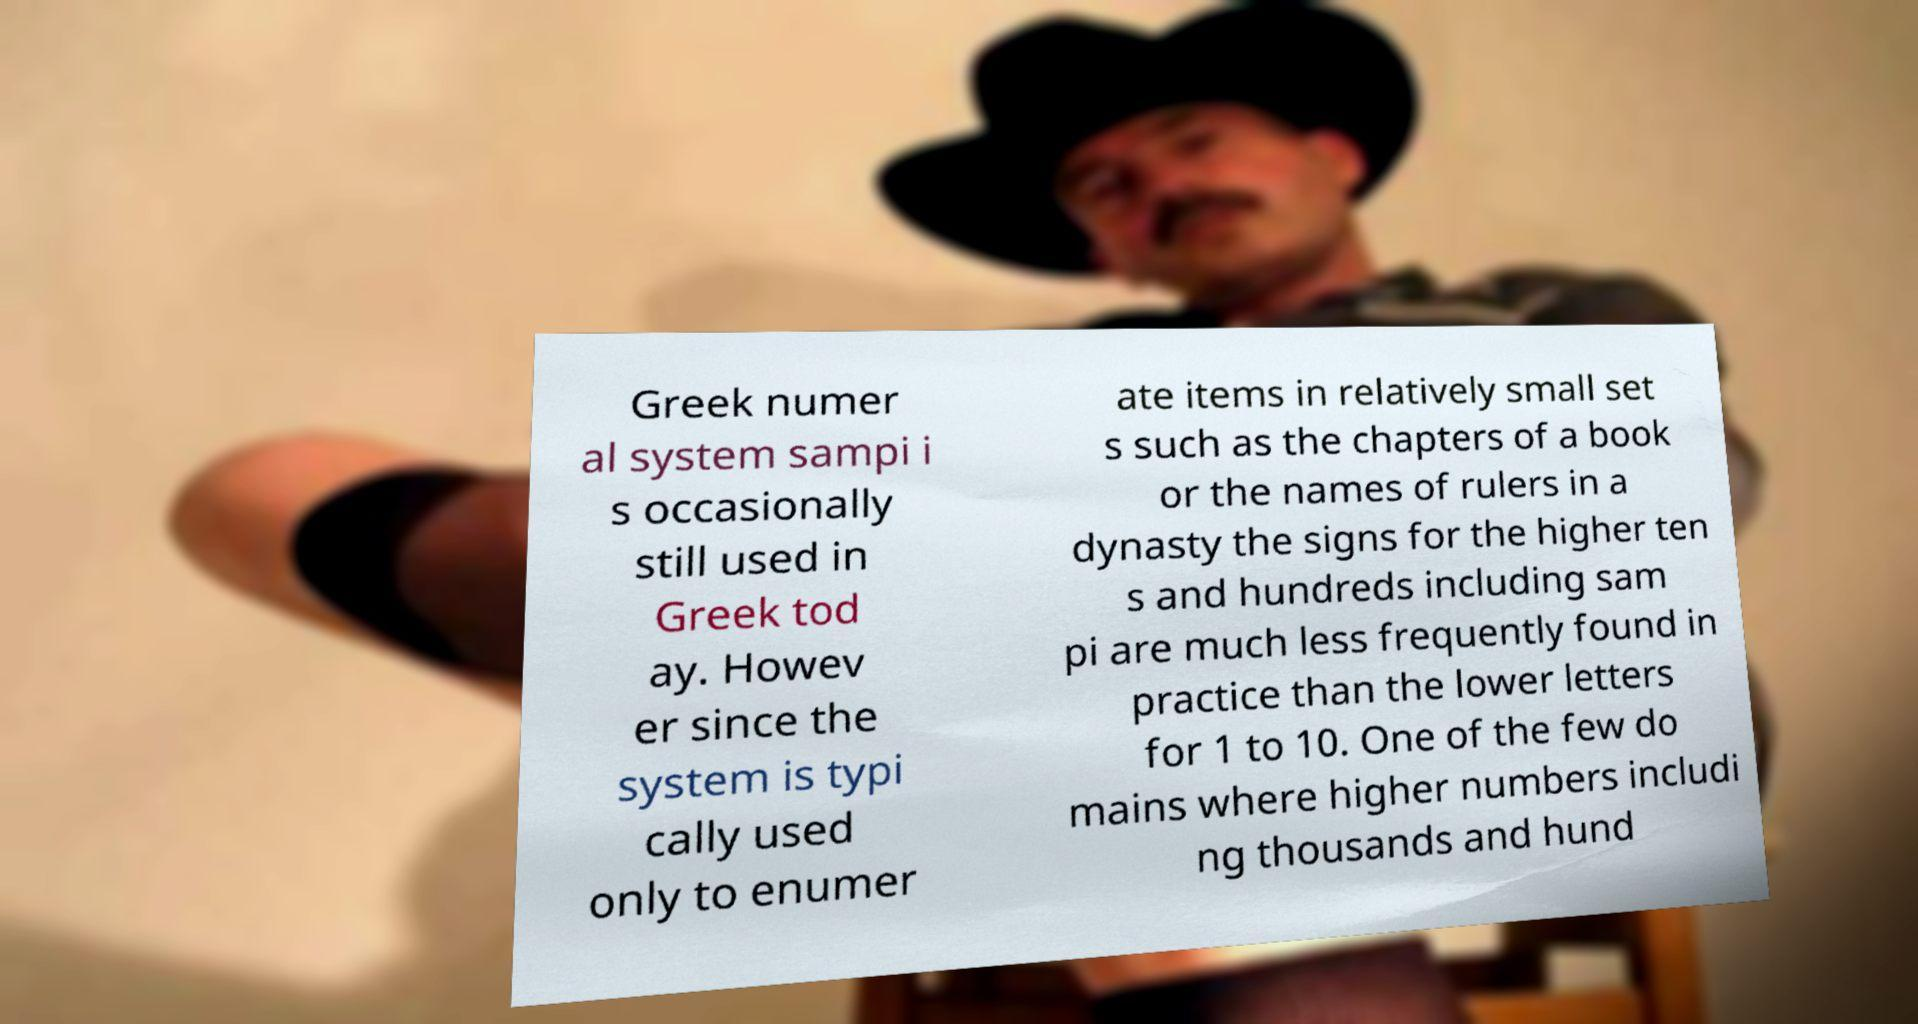Can you read and provide the text displayed in the image?This photo seems to have some interesting text. Can you extract and type it out for me? Greek numer al system sampi i s occasionally still used in Greek tod ay. Howev er since the system is typi cally used only to enumer ate items in relatively small set s such as the chapters of a book or the names of rulers in a dynasty the signs for the higher ten s and hundreds including sam pi are much less frequently found in practice than the lower letters for 1 to 10. One of the few do mains where higher numbers includi ng thousands and hund 